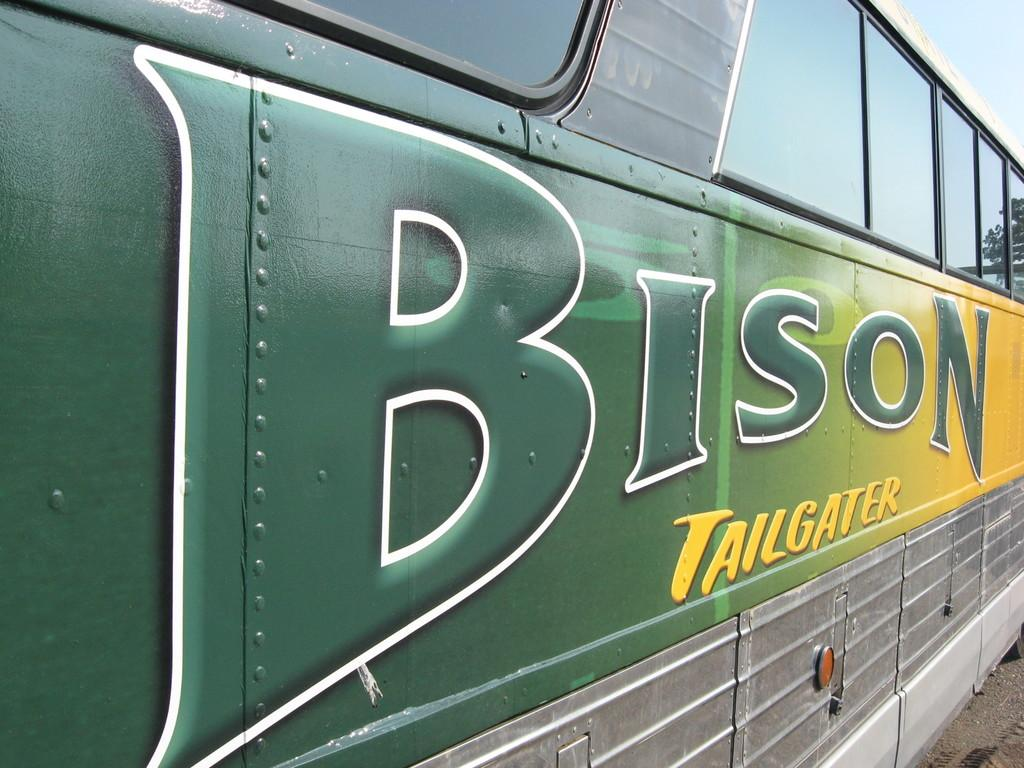<image>
Present a compact description of the photo's key features. a bus with the words 'bison tailgater' on the side of it 